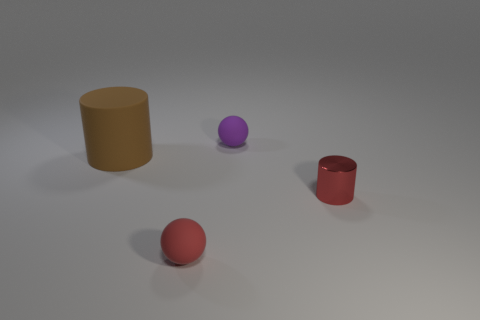Add 3 large blue matte blocks. How many objects exist? 7 Subtract 0 blue balls. How many objects are left? 4 Subtract all cyan spheres. Subtract all green cylinders. How many spheres are left? 2 Subtract all small cylinders. Subtract all tiny purple objects. How many objects are left? 2 Add 1 tiny matte things. How many tiny matte things are left? 3 Add 1 tiny things. How many tiny things exist? 4 